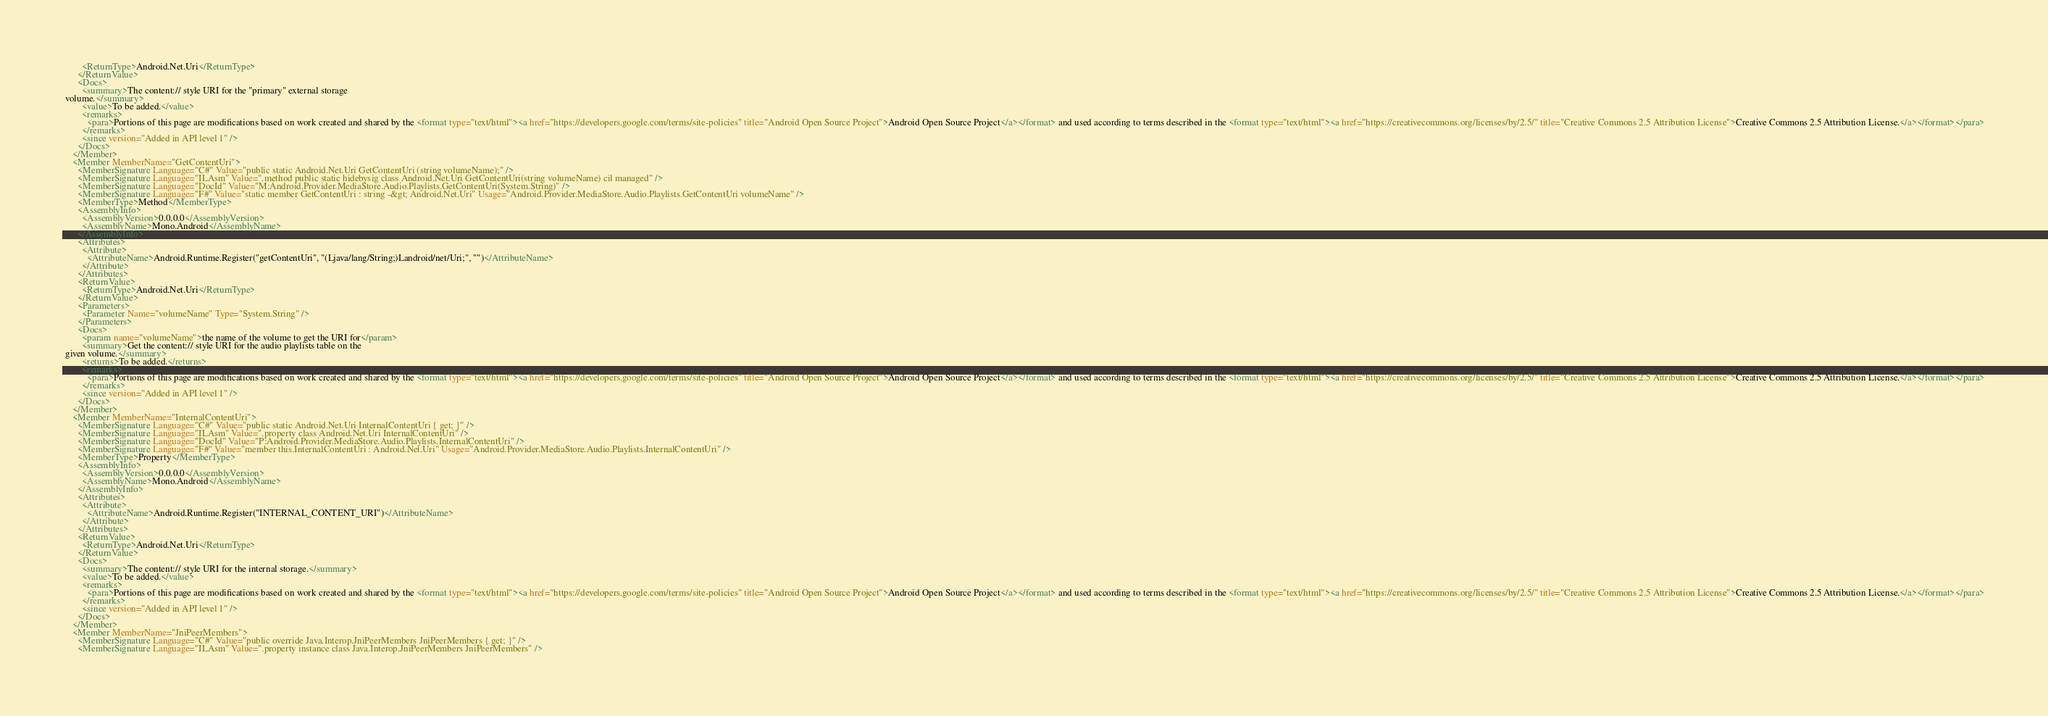<code> <loc_0><loc_0><loc_500><loc_500><_XML_>        <ReturnType>Android.Net.Uri</ReturnType>
      </ReturnValue>
      <Docs>
        <summary>The content:// style URI for the "primary" external storage
 volume.</summary>
        <value>To be added.</value>
        <remarks>
          <para>Portions of this page are modifications based on work created and shared by the <format type="text/html"><a href="https://developers.google.com/terms/site-policies" title="Android Open Source Project">Android Open Source Project</a></format> and used according to terms described in the <format type="text/html"><a href="https://creativecommons.org/licenses/by/2.5/" title="Creative Commons 2.5 Attribution License">Creative Commons 2.5 Attribution License.</a></format></para>
        </remarks>
        <since version="Added in API level 1" />
      </Docs>
    </Member>
    <Member MemberName="GetContentUri">
      <MemberSignature Language="C#" Value="public static Android.Net.Uri GetContentUri (string volumeName);" />
      <MemberSignature Language="ILAsm" Value=".method public static hidebysig class Android.Net.Uri GetContentUri(string volumeName) cil managed" />
      <MemberSignature Language="DocId" Value="M:Android.Provider.MediaStore.Audio.Playlists.GetContentUri(System.String)" />
      <MemberSignature Language="F#" Value="static member GetContentUri : string -&gt; Android.Net.Uri" Usage="Android.Provider.MediaStore.Audio.Playlists.GetContentUri volumeName" />
      <MemberType>Method</MemberType>
      <AssemblyInfo>
        <AssemblyVersion>0.0.0.0</AssemblyVersion>
        <AssemblyName>Mono.Android</AssemblyName>
      </AssemblyInfo>
      <Attributes>
        <Attribute>
          <AttributeName>Android.Runtime.Register("getContentUri", "(Ljava/lang/String;)Landroid/net/Uri;", "")</AttributeName>
        </Attribute>
      </Attributes>
      <ReturnValue>
        <ReturnType>Android.Net.Uri</ReturnType>
      </ReturnValue>
      <Parameters>
        <Parameter Name="volumeName" Type="System.String" />
      </Parameters>
      <Docs>
        <param name="volumeName">the name of the volume to get the URI for</param>
        <summary>Get the content:// style URI for the audio playlists table on the
 given volume.</summary>
        <returns>To be added.</returns>
        <remarks>
          <para>Portions of this page are modifications based on work created and shared by the <format type="text/html"><a href="https://developers.google.com/terms/site-policies" title="Android Open Source Project">Android Open Source Project</a></format> and used according to terms described in the <format type="text/html"><a href="https://creativecommons.org/licenses/by/2.5/" title="Creative Commons 2.5 Attribution License">Creative Commons 2.5 Attribution License.</a></format></para>
        </remarks>
        <since version="Added in API level 1" />
      </Docs>
    </Member>
    <Member MemberName="InternalContentUri">
      <MemberSignature Language="C#" Value="public static Android.Net.Uri InternalContentUri { get; }" />
      <MemberSignature Language="ILAsm" Value=".property class Android.Net.Uri InternalContentUri" />
      <MemberSignature Language="DocId" Value="P:Android.Provider.MediaStore.Audio.Playlists.InternalContentUri" />
      <MemberSignature Language="F#" Value="member this.InternalContentUri : Android.Net.Uri" Usage="Android.Provider.MediaStore.Audio.Playlists.InternalContentUri" />
      <MemberType>Property</MemberType>
      <AssemblyInfo>
        <AssemblyVersion>0.0.0.0</AssemblyVersion>
        <AssemblyName>Mono.Android</AssemblyName>
      </AssemblyInfo>
      <Attributes>
        <Attribute>
          <AttributeName>Android.Runtime.Register("INTERNAL_CONTENT_URI")</AttributeName>
        </Attribute>
      </Attributes>
      <ReturnValue>
        <ReturnType>Android.Net.Uri</ReturnType>
      </ReturnValue>
      <Docs>
        <summary>The content:// style URI for the internal storage.</summary>
        <value>To be added.</value>
        <remarks>
          <para>Portions of this page are modifications based on work created and shared by the <format type="text/html"><a href="https://developers.google.com/terms/site-policies" title="Android Open Source Project">Android Open Source Project</a></format> and used according to terms described in the <format type="text/html"><a href="https://creativecommons.org/licenses/by/2.5/" title="Creative Commons 2.5 Attribution License">Creative Commons 2.5 Attribution License.</a></format></para>
        </remarks>
        <since version="Added in API level 1" />
      </Docs>
    </Member>
    <Member MemberName="JniPeerMembers">
      <MemberSignature Language="C#" Value="public override Java.Interop.JniPeerMembers JniPeerMembers { get; }" />
      <MemberSignature Language="ILAsm" Value=".property instance class Java.Interop.JniPeerMembers JniPeerMembers" /></code> 